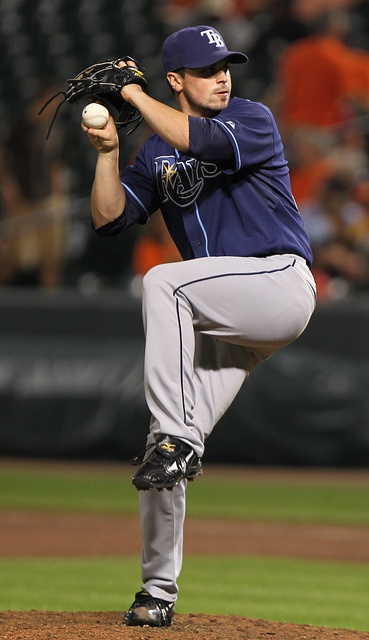Describe the objects in this image and their specific colors. I can see people in black, lightgray, navy, and darkgray tones, people in black, maroon, and brown tones, baseball glove in black, gray, and darkgray tones, and sports ball in black, beige, and tan tones in this image. 